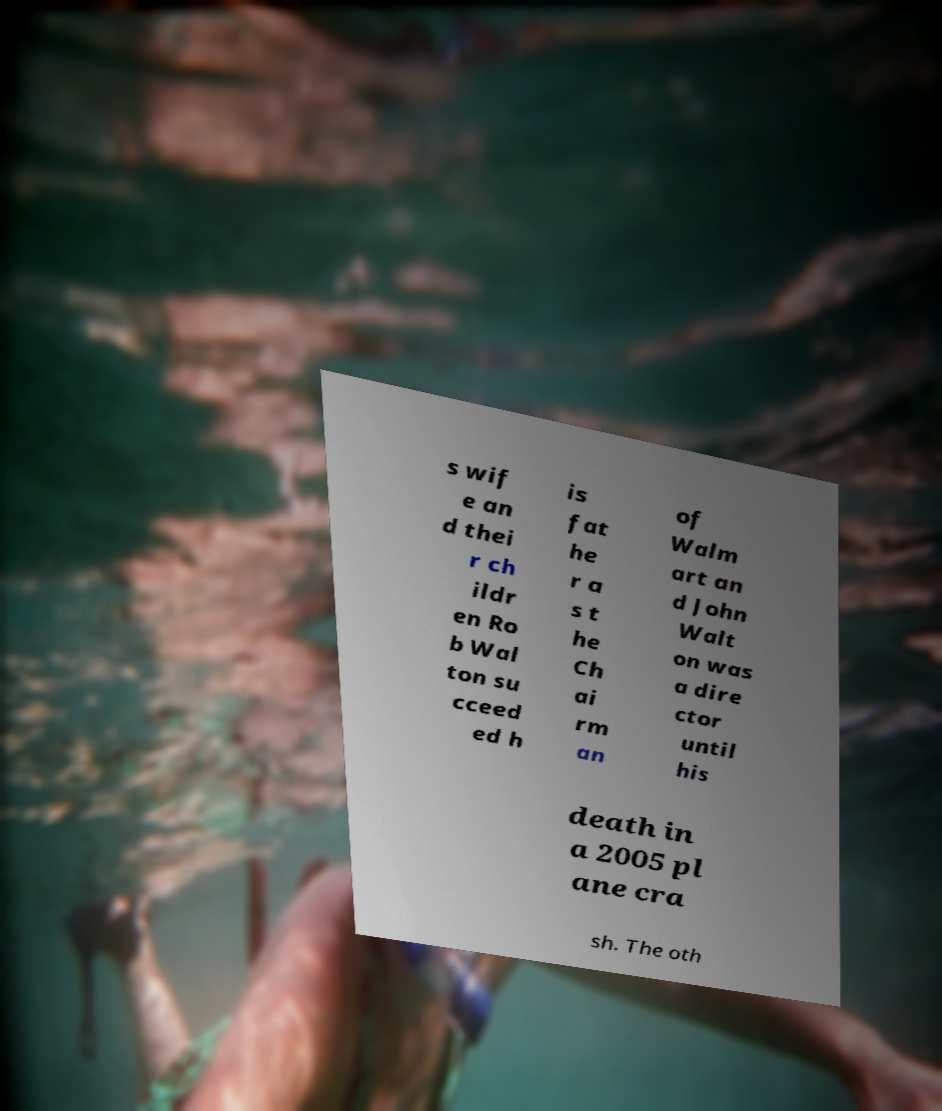Please read and relay the text visible in this image. What does it say? s wif e an d thei r ch ildr en Ro b Wal ton su cceed ed h is fat he r a s t he Ch ai rm an of Walm art an d John Walt on was a dire ctor until his death in a 2005 pl ane cra sh. The oth 